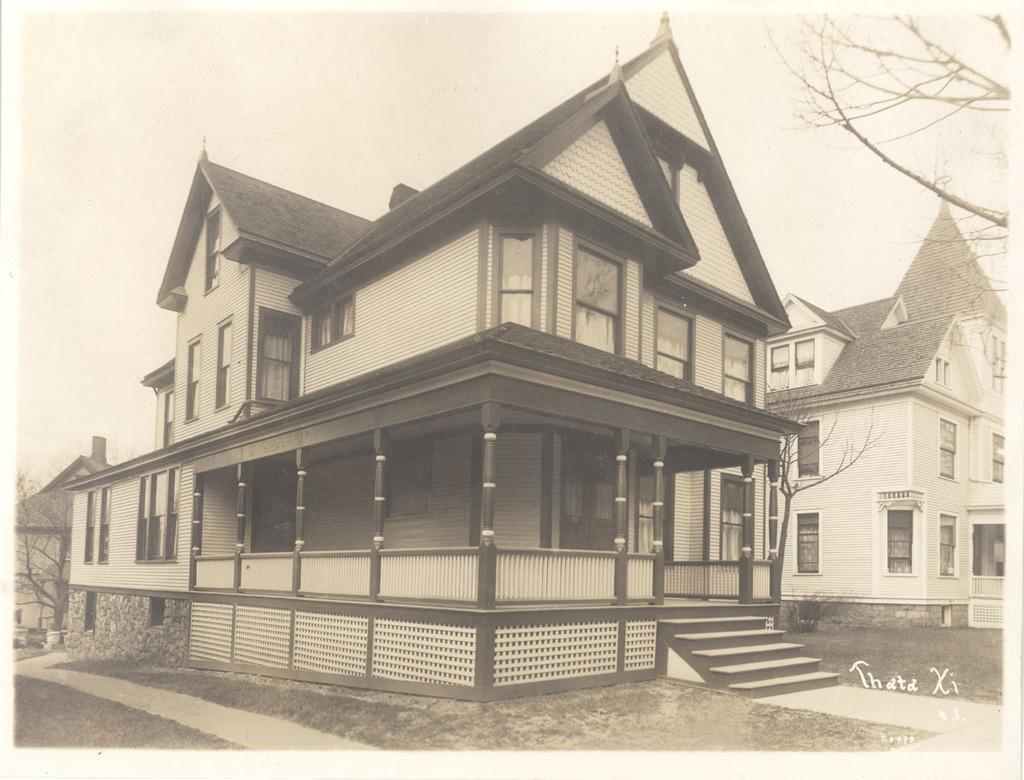What type: What type of structures are present in the image? There are homes in the image. Where is the tree located in the image? The tree is at the right side top of the image. What is visible at the top of the image? The sky is visible at the top of the image. How many corks can be seen floating in the image? There are no corks present in the image. 